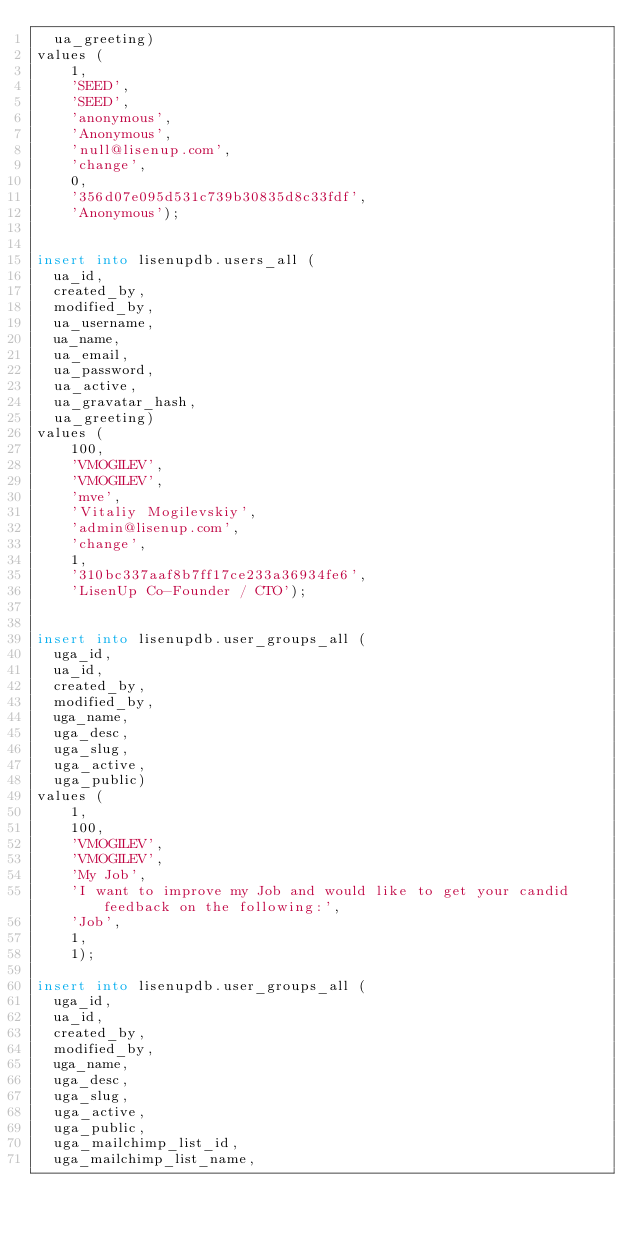<code> <loc_0><loc_0><loc_500><loc_500><_SQL_>  ua_greeting)
values (
    1,
    'SEED',
    'SEED',
    'anonymous',
    'Anonymous',
    'null@lisenup.com',
    'change',
    0,
    '356d07e095d531c739b30835d8c33fdf',
    'Anonymous');


insert into lisenupdb.users_all (
  ua_id,
  created_by,
  modified_by,
  ua_username,
  ua_name,
  ua_email,
  ua_password,
  ua_active,
  ua_gravatar_hash,
  ua_greeting)
values (
    100,
    'VMOGILEV',
    'VMOGILEV',
    'mve',
    'Vitaliy Mogilevskiy',
    'admin@lisenup.com',
    'change',
    1,
    '310bc337aaf8b7ff17ce233a36934fe6',
    'LisenUp Co-Founder / CTO');


insert into lisenupdb.user_groups_all (
  uga_id,
  ua_id,
  created_by,
  modified_by,
  uga_name,
  uga_desc,
  uga_slug,
  uga_active,
  uga_public)
values (
    1,
    100,
    'VMOGILEV',
    'VMOGILEV',
    'My Job',
    'I want to improve my Job and would like to get your candid feedback on the following:',
    'Job',
    1,
    1);

insert into lisenupdb.user_groups_all (
  uga_id,
  ua_id,
  created_by,
  modified_by,
  uga_name,
  uga_desc,
  uga_slug,
  uga_active,
  uga_public,
  uga_mailchimp_list_id,
  uga_mailchimp_list_name,</code> 